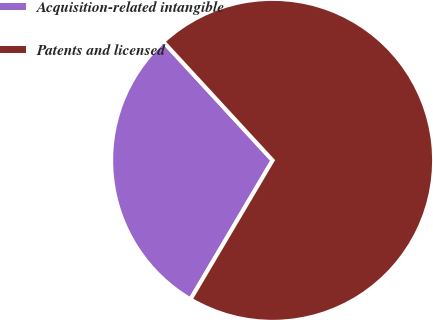Convert chart to OTSL. <chart><loc_0><loc_0><loc_500><loc_500><pie_chart><fcel>Acquisition-related intangible<fcel>Patents and licensed<nl><fcel>29.66%<fcel>70.34%<nl></chart> 